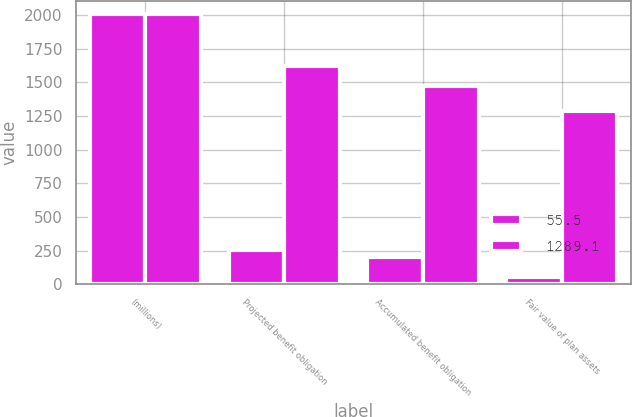<chart> <loc_0><loc_0><loc_500><loc_500><stacked_bar_chart><ecel><fcel>(millions)<fcel>Projected benefit obligation<fcel>Accumulated benefit obligation<fcel>Fair value of plan assets<nl><fcel>55.5<fcel>2006<fcel>253.4<fcel>202.5<fcel>55.5<nl><fcel>1289.1<fcel>2005<fcel>1621.4<fcel>1473.7<fcel>1289.1<nl></chart> 